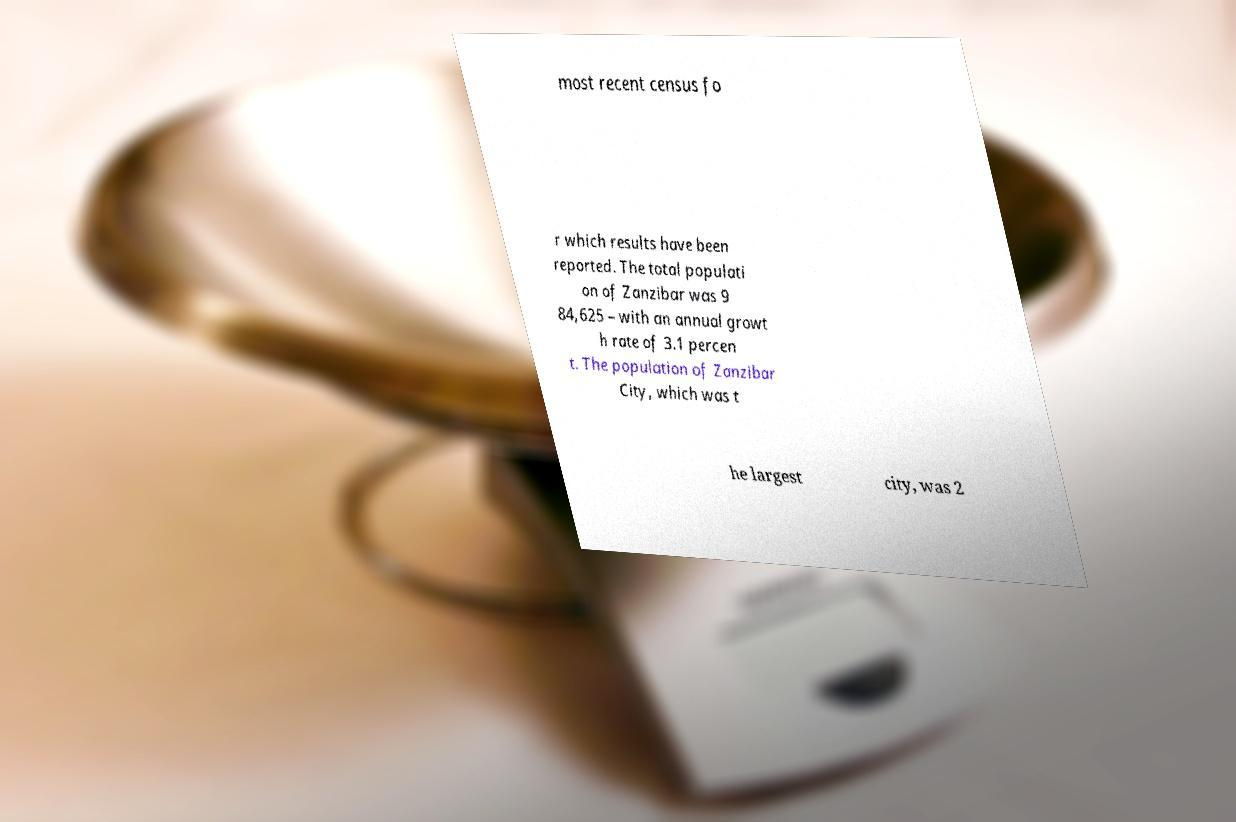Can you accurately transcribe the text from the provided image for me? most recent census fo r which results have been reported. The total populati on of Zanzibar was 9 84,625 – with an annual growt h rate of 3.1 percen t. The population of Zanzibar City, which was t he largest city, was 2 